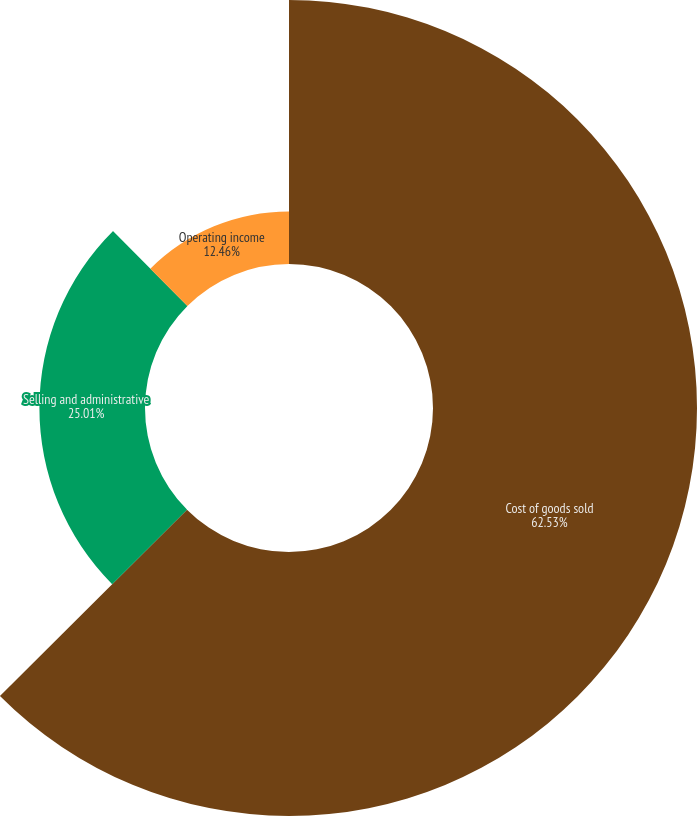<chart> <loc_0><loc_0><loc_500><loc_500><pie_chart><fcel>Cost of goods sold<fcel>Selling and administrative<fcel>Operating income<nl><fcel>62.53%<fcel>25.01%<fcel>12.46%<nl></chart> 